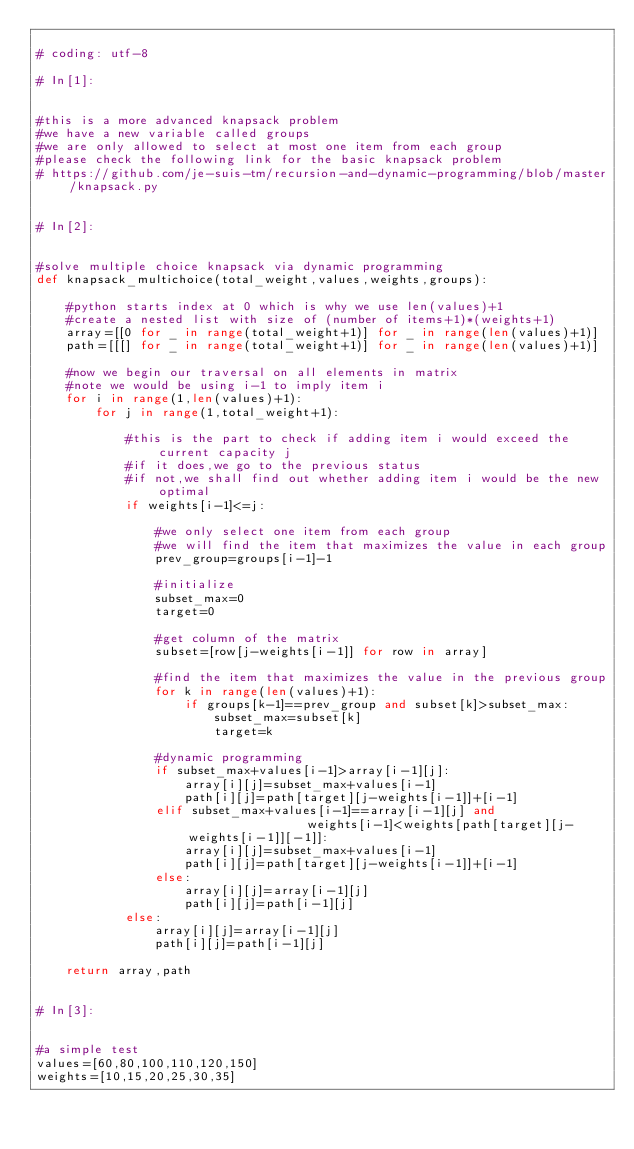<code> <loc_0><loc_0><loc_500><loc_500><_Python_>
# coding: utf-8

# In[1]:


#this is a more advanced knapsack problem
#we have a new variable called groups
#we are only allowed to select at most one item from each group
#please check the following link for the basic knapsack problem
# https://github.com/je-suis-tm/recursion-and-dynamic-programming/blob/master/knapsack.py


# In[2]:


#solve multiple choice knapsack via dynamic programming
def knapsack_multichoice(total_weight,values,weights,groups):
        
    #python starts index at 0 which is why we use len(values)+1
    #create a nested list with size of (number of items+1)*(weights+1)
    array=[[0 for _ in range(total_weight+1)] for _ in range(len(values)+1)] 
    path=[[[] for _ in range(total_weight+1)] for _ in range(len(values)+1)]

    #now we begin our traversal on all elements in matrix
    #note we would be using i-1 to imply item i
    for i in range(1,len(values)+1):
        for j in range(1,total_weight+1):                         
                
            #this is the part to check if adding item i would exceed the current capacity j
            #if it does,we go to the previous status
            #if not,we shall find out whether adding item i would be the new optimal
            if weights[i-1]<=j:
                
                #we only select one item from each group
                #we will find the item that maximizes the value in each group
                prev_group=groups[i-1]-1
                
                #initialize
                subset_max=0
                target=0                
                
                #get column of the matrix
                subset=[row[j-weights[i-1]] for row in array]
                
                #find the item that maximizes the value in the previous group
                for k in range(len(values)+1):
                    if groups[k-1]==prev_group and subset[k]>subset_max:
                        subset_max=subset[k]
                        target=k
                                        
                #dynamic programming
                if subset_max+values[i-1]>array[i-1][j]:
                    array[i][j]=subset_max+values[i-1]
                    path[i][j]=path[target][j-weights[i-1]]+[i-1]
                elif subset_max+values[i-1]==array[i-1][j] and                 weights[i-1]<weights[path[target][j-weights[i-1]][-1]]:
                    array[i][j]=subset_max+values[i-1]
                    path[i][j]=path[target][j-weights[i-1]]+[i-1]
                else:
                    array[i][j]=array[i-1][j]
                    path[i][j]=path[i-1][j]
            else:                 
                array[i][j]=array[i-1][j]
                path[i][j]=path[i-1][j]

    return array,path


# In[3]:


#a simple test
values=[60,80,100,110,120,150] 
weights=[10,15,20,25,30,35] </code> 